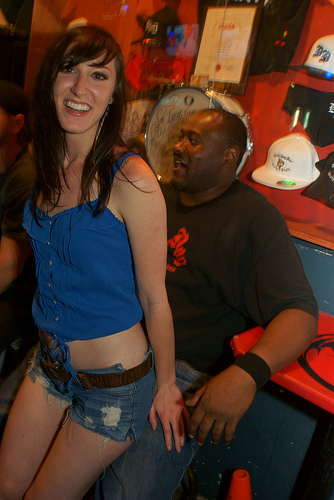<image>
Is there a woman on the lap? Yes. Looking at the image, I can see the woman is positioned on top of the lap, with the lap providing support. Where is the woman in relation to the man? Is it on the man? Yes. Looking at the image, I can see the woman is positioned on top of the man, with the man providing support. Is the man under the woman? Yes. The man is positioned underneath the woman, with the woman above it in the vertical space. Is there a girl next to the white hat? No. The girl is not positioned next to the white hat. They are located in different areas of the scene. 